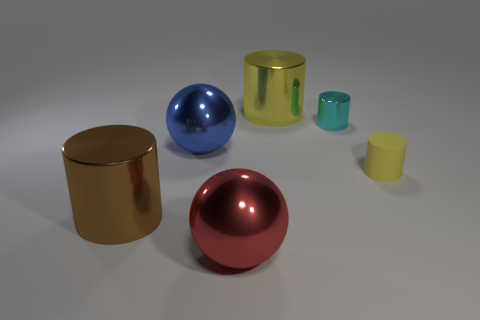Add 1 large blue shiny objects. How many objects exist? 7 Subtract all cylinders. How many objects are left? 2 Subtract 0 purple cylinders. How many objects are left? 6 Subtract all large things. Subtract all brown metallic things. How many objects are left? 1 Add 6 large brown metallic things. How many large brown metallic things are left? 7 Add 5 small gray rubber things. How many small gray rubber things exist? 5 